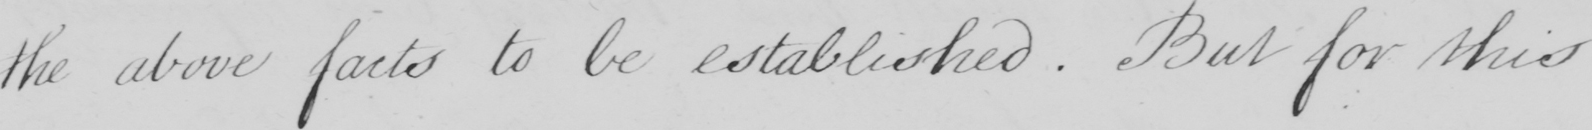Transcribe the text shown in this historical manuscript line. the above facts to be established . But for this 